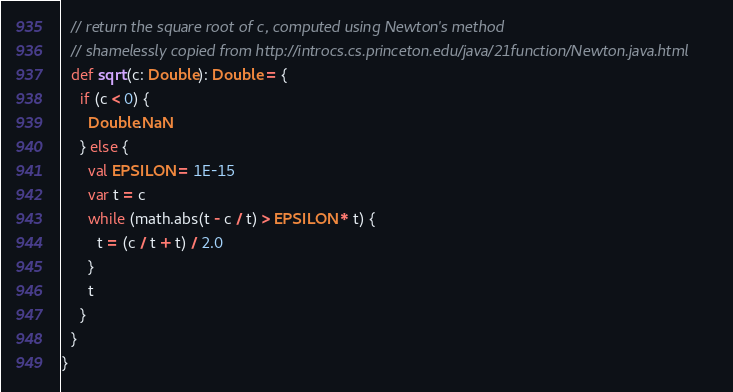Convert code to text. <code><loc_0><loc_0><loc_500><loc_500><_Scala_>
  // return the square root of c, computed using Newton's method
  // shamelessly copied from http://introcs.cs.princeton.edu/java/21function/Newton.java.html
  def sqrt(c: Double): Double = {
    if (c < 0) {
      Double.NaN
    } else {
      val EPSILON = 1E-15
      var t = c
      while (math.abs(t - c / t) > EPSILON * t) {
        t = (c / t + t) / 2.0
      }
      t
    }
  }
}
</code> 